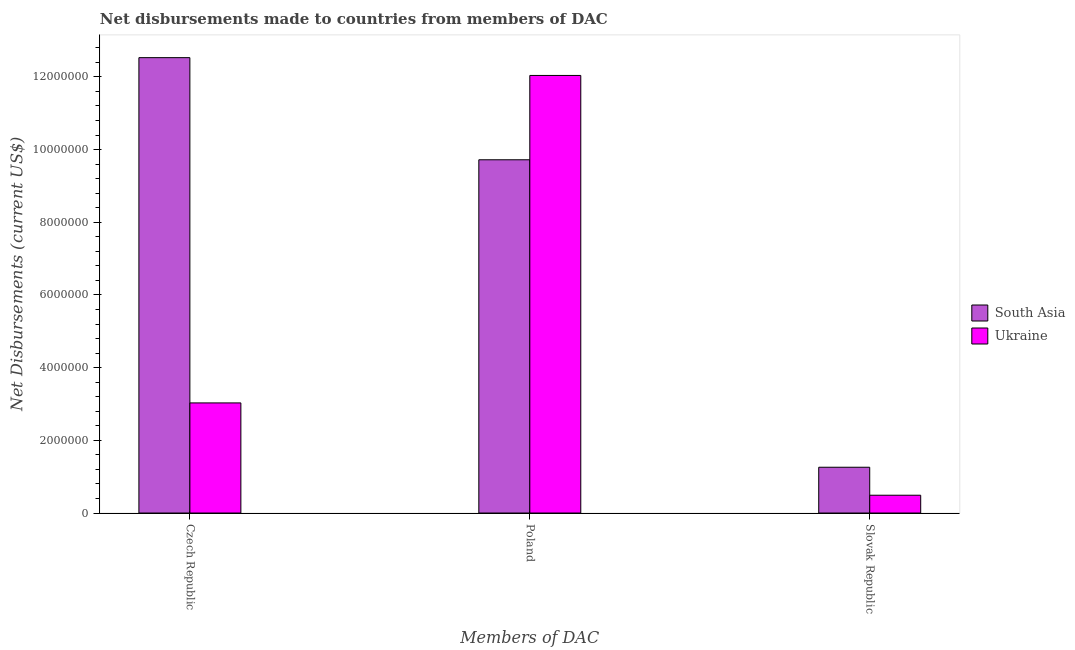How many different coloured bars are there?
Provide a succinct answer. 2. How many groups of bars are there?
Your answer should be compact. 3. Are the number of bars per tick equal to the number of legend labels?
Make the answer very short. Yes. Are the number of bars on each tick of the X-axis equal?
Give a very brief answer. Yes. How many bars are there on the 1st tick from the left?
Your answer should be compact. 2. How many bars are there on the 2nd tick from the right?
Make the answer very short. 2. What is the label of the 2nd group of bars from the left?
Provide a short and direct response. Poland. What is the net disbursements made by slovak republic in Ukraine?
Your answer should be compact. 4.90e+05. Across all countries, what is the maximum net disbursements made by czech republic?
Your response must be concise. 1.25e+07. Across all countries, what is the minimum net disbursements made by czech republic?
Give a very brief answer. 3.03e+06. In which country was the net disbursements made by poland maximum?
Offer a very short reply. Ukraine. In which country was the net disbursements made by slovak republic minimum?
Make the answer very short. Ukraine. What is the total net disbursements made by poland in the graph?
Your response must be concise. 2.18e+07. What is the difference between the net disbursements made by slovak republic in Ukraine and that in South Asia?
Give a very brief answer. -7.70e+05. What is the difference between the net disbursements made by poland in South Asia and the net disbursements made by czech republic in Ukraine?
Your answer should be compact. 6.69e+06. What is the average net disbursements made by poland per country?
Offer a terse response. 1.09e+07. What is the difference between the net disbursements made by poland and net disbursements made by slovak republic in South Asia?
Ensure brevity in your answer.  8.46e+06. What is the ratio of the net disbursements made by czech republic in Ukraine to that in South Asia?
Provide a short and direct response. 0.24. Is the difference between the net disbursements made by poland in South Asia and Ukraine greater than the difference between the net disbursements made by czech republic in South Asia and Ukraine?
Give a very brief answer. No. What is the difference between the highest and the second highest net disbursements made by slovak republic?
Offer a terse response. 7.70e+05. What is the difference between the highest and the lowest net disbursements made by czech republic?
Ensure brevity in your answer.  9.50e+06. In how many countries, is the net disbursements made by poland greater than the average net disbursements made by poland taken over all countries?
Keep it short and to the point. 1. What does the 2nd bar from the left in Poland represents?
Give a very brief answer. Ukraine. Is it the case that in every country, the sum of the net disbursements made by czech republic and net disbursements made by poland is greater than the net disbursements made by slovak republic?
Your answer should be very brief. Yes. How many countries are there in the graph?
Your answer should be very brief. 2. Does the graph contain any zero values?
Offer a very short reply. No. Does the graph contain grids?
Give a very brief answer. No. Where does the legend appear in the graph?
Offer a terse response. Center right. How many legend labels are there?
Provide a succinct answer. 2. What is the title of the graph?
Ensure brevity in your answer.  Net disbursements made to countries from members of DAC. Does "Botswana" appear as one of the legend labels in the graph?
Give a very brief answer. No. What is the label or title of the X-axis?
Offer a very short reply. Members of DAC. What is the label or title of the Y-axis?
Your answer should be compact. Net Disbursements (current US$). What is the Net Disbursements (current US$) of South Asia in Czech Republic?
Make the answer very short. 1.25e+07. What is the Net Disbursements (current US$) of Ukraine in Czech Republic?
Offer a terse response. 3.03e+06. What is the Net Disbursements (current US$) in South Asia in Poland?
Give a very brief answer. 9.72e+06. What is the Net Disbursements (current US$) of Ukraine in Poland?
Keep it short and to the point. 1.20e+07. What is the Net Disbursements (current US$) in South Asia in Slovak Republic?
Ensure brevity in your answer.  1.26e+06. Across all Members of DAC, what is the maximum Net Disbursements (current US$) in South Asia?
Offer a terse response. 1.25e+07. Across all Members of DAC, what is the maximum Net Disbursements (current US$) of Ukraine?
Provide a succinct answer. 1.20e+07. Across all Members of DAC, what is the minimum Net Disbursements (current US$) in South Asia?
Offer a terse response. 1.26e+06. What is the total Net Disbursements (current US$) of South Asia in the graph?
Provide a short and direct response. 2.35e+07. What is the total Net Disbursements (current US$) in Ukraine in the graph?
Make the answer very short. 1.56e+07. What is the difference between the Net Disbursements (current US$) in South Asia in Czech Republic and that in Poland?
Your response must be concise. 2.81e+06. What is the difference between the Net Disbursements (current US$) of Ukraine in Czech Republic and that in Poland?
Your response must be concise. -9.01e+06. What is the difference between the Net Disbursements (current US$) of South Asia in Czech Republic and that in Slovak Republic?
Ensure brevity in your answer.  1.13e+07. What is the difference between the Net Disbursements (current US$) of Ukraine in Czech Republic and that in Slovak Republic?
Give a very brief answer. 2.54e+06. What is the difference between the Net Disbursements (current US$) in South Asia in Poland and that in Slovak Republic?
Provide a short and direct response. 8.46e+06. What is the difference between the Net Disbursements (current US$) of Ukraine in Poland and that in Slovak Republic?
Your answer should be compact. 1.16e+07. What is the difference between the Net Disbursements (current US$) in South Asia in Czech Republic and the Net Disbursements (current US$) in Ukraine in Slovak Republic?
Provide a short and direct response. 1.20e+07. What is the difference between the Net Disbursements (current US$) in South Asia in Poland and the Net Disbursements (current US$) in Ukraine in Slovak Republic?
Your answer should be very brief. 9.23e+06. What is the average Net Disbursements (current US$) in South Asia per Members of DAC?
Your answer should be very brief. 7.84e+06. What is the average Net Disbursements (current US$) in Ukraine per Members of DAC?
Your answer should be compact. 5.19e+06. What is the difference between the Net Disbursements (current US$) in South Asia and Net Disbursements (current US$) in Ukraine in Czech Republic?
Offer a terse response. 9.50e+06. What is the difference between the Net Disbursements (current US$) of South Asia and Net Disbursements (current US$) of Ukraine in Poland?
Your answer should be compact. -2.32e+06. What is the difference between the Net Disbursements (current US$) of South Asia and Net Disbursements (current US$) of Ukraine in Slovak Republic?
Make the answer very short. 7.70e+05. What is the ratio of the Net Disbursements (current US$) of South Asia in Czech Republic to that in Poland?
Provide a short and direct response. 1.29. What is the ratio of the Net Disbursements (current US$) of Ukraine in Czech Republic to that in Poland?
Provide a short and direct response. 0.25. What is the ratio of the Net Disbursements (current US$) in South Asia in Czech Republic to that in Slovak Republic?
Provide a short and direct response. 9.94. What is the ratio of the Net Disbursements (current US$) of Ukraine in Czech Republic to that in Slovak Republic?
Provide a succinct answer. 6.18. What is the ratio of the Net Disbursements (current US$) in South Asia in Poland to that in Slovak Republic?
Your response must be concise. 7.71. What is the ratio of the Net Disbursements (current US$) in Ukraine in Poland to that in Slovak Republic?
Your answer should be very brief. 24.57. What is the difference between the highest and the second highest Net Disbursements (current US$) of South Asia?
Your answer should be very brief. 2.81e+06. What is the difference between the highest and the second highest Net Disbursements (current US$) of Ukraine?
Ensure brevity in your answer.  9.01e+06. What is the difference between the highest and the lowest Net Disbursements (current US$) in South Asia?
Your response must be concise. 1.13e+07. What is the difference between the highest and the lowest Net Disbursements (current US$) of Ukraine?
Offer a very short reply. 1.16e+07. 